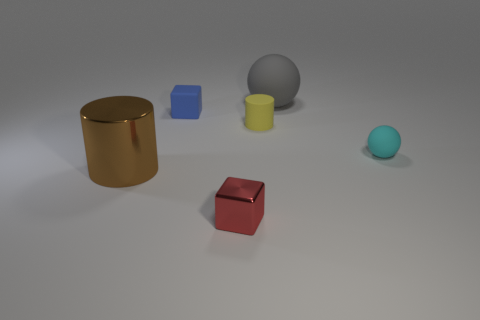There is a cube behind the small metallic cube; is it the same size as the shiny object that is behind the red metal thing?
Ensure brevity in your answer.  No. How many other things are the same size as the brown shiny cylinder?
Make the answer very short. 1. What material is the cube in front of the small thing that is on the right side of the rubber thing behind the rubber cube made of?
Your response must be concise. Metal. There is a gray rubber object; is it the same size as the blue matte thing that is in front of the large gray ball?
Give a very brief answer. No. How big is the matte thing that is both right of the yellow object and in front of the big gray rubber object?
Make the answer very short. Small. There is a sphere right of the large thing that is on the right side of the rubber cylinder; what color is it?
Make the answer very short. Cyan. Are there fewer large gray matte objects in front of the cyan rubber object than large brown cylinders that are left of the big gray ball?
Offer a terse response. Yes. Is the size of the gray thing the same as the cyan matte thing?
Keep it short and to the point. No. There is a matte thing that is on the left side of the gray matte ball and behind the small matte cylinder; what shape is it?
Provide a short and direct response. Cube. What number of large balls have the same material as the tiny yellow cylinder?
Give a very brief answer. 1. 